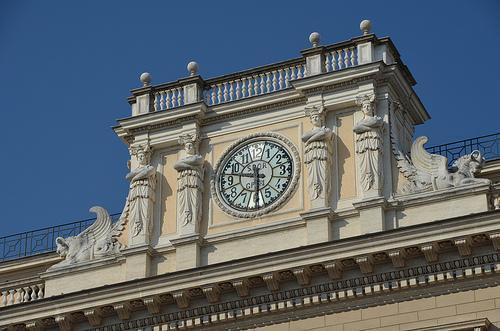How many human statues are to the left of the clock face?
Give a very brief answer. 2. 